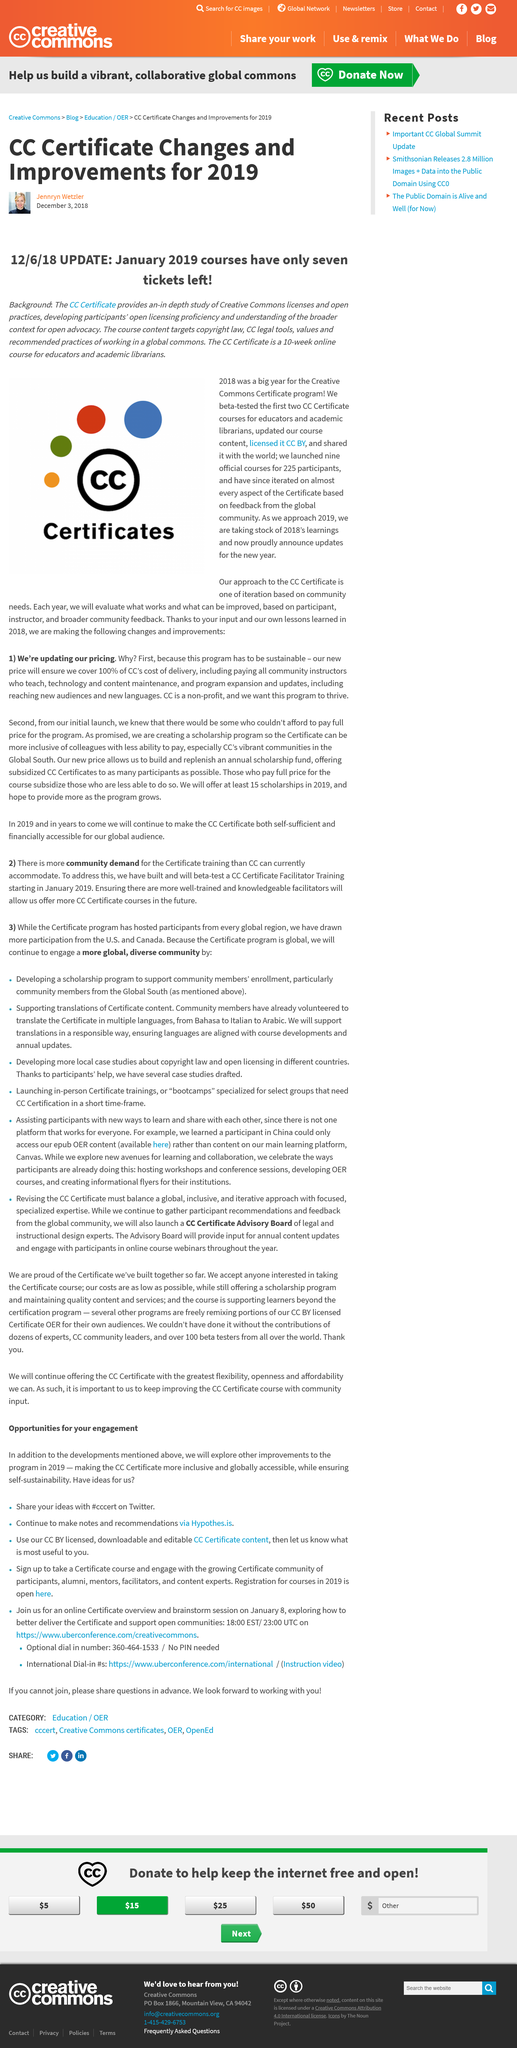Point out several critical features in this image. The CC Certificate course is 10 weeks in length. The CC Certificate course is intended for educators and academic libraries. 